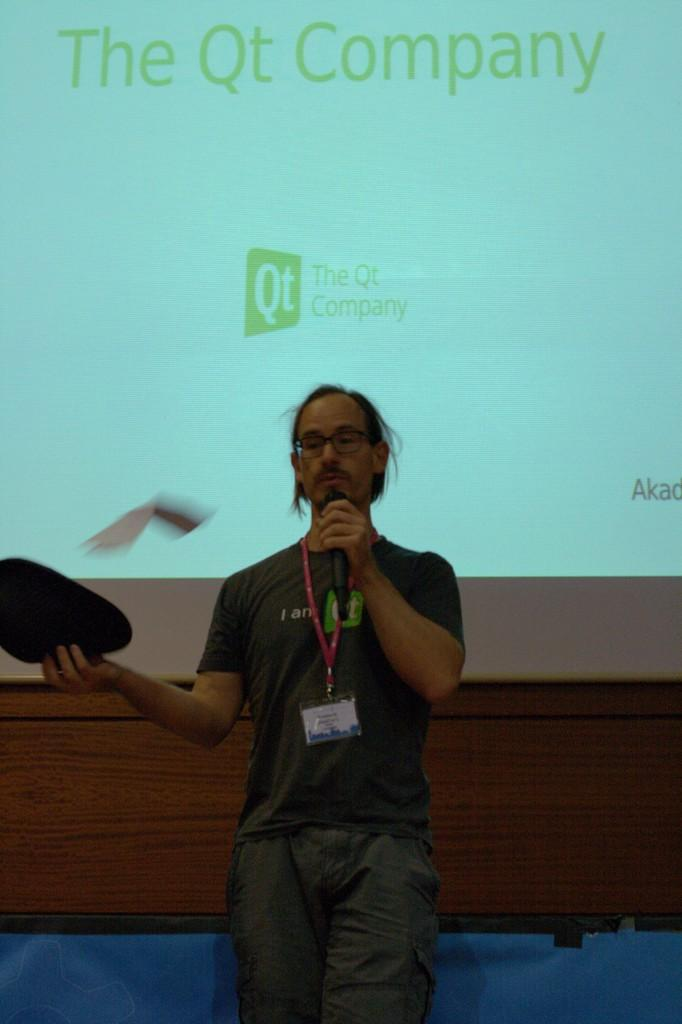What is the man doing on the stage in the image? The man is standing on the stage and speaking into a microphone. What might be used to amplify the man's voice in the image? The man is speaking into a microphone, which is used to amplify his voice. What is located behind the man on the stage? There is a screen behind the man on the stage. What type of orange is visible on the back of the man in the image? There is no orange present in the image, and the man's back is not visible. 